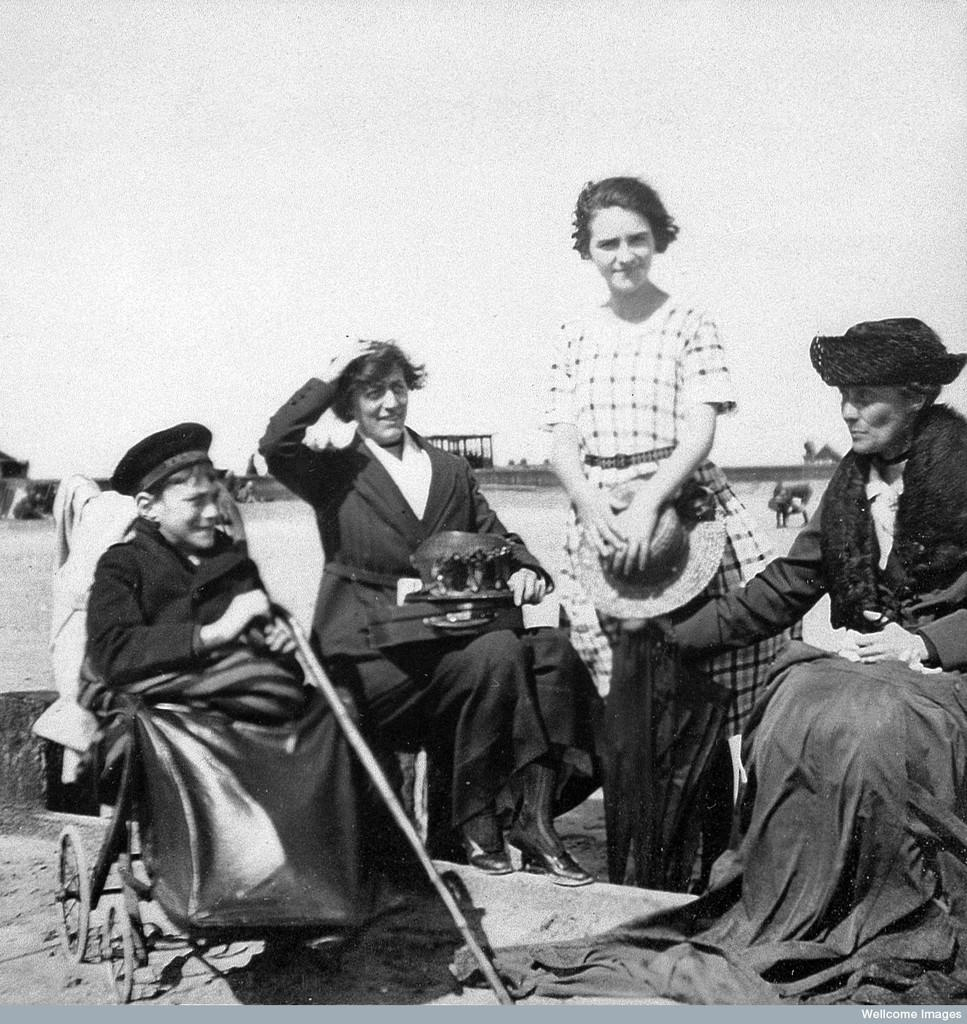How many people are in the image? There is a group of people in the image. What is one person in the group doing? One person is sitting and holding a stick. What is the color scheme of the image? The image is in black and white. What can be seen in the background of the image? There are objects visible in the background. What society does the group of people belong to in the image? The image does not provide any information about the society or group affiliation of the people. What wish does the person holding the stick have in the image? There is no indication of any wishes or desires in the image; the person is simply sitting and holding a stick. 